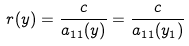Convert formula to latex. <formula><loc_0><loc_0><loc_500><loc_500>r ( y ) = \frac { c } { a _ { 1 1 } ( y ) } = \frac { c } { a _ { 1 1 } ( y _ { 1 } ) }</formula> 